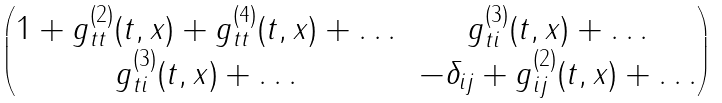Convert formula to latex. <formula><loc_0><loc_0><loc_500><loc_500>\begin{pmatrix} 1 + g ^ { ( 2 ) } _ { t t } ( t , x ) + g ^ { ( 4 ) } _ { t t } ( t , x ) + \dots & g ^ { ( 3 ) } _ { t i } ( t , x ) + \dots \\ g ^ { ( 3 ) } _ { t i } ( t , x ) + \dots & - \delta _ { i j } + g ^ { ( 2 ) } _ { i j } ( t , x ) + \dots \end{pmatrix}</formula> 